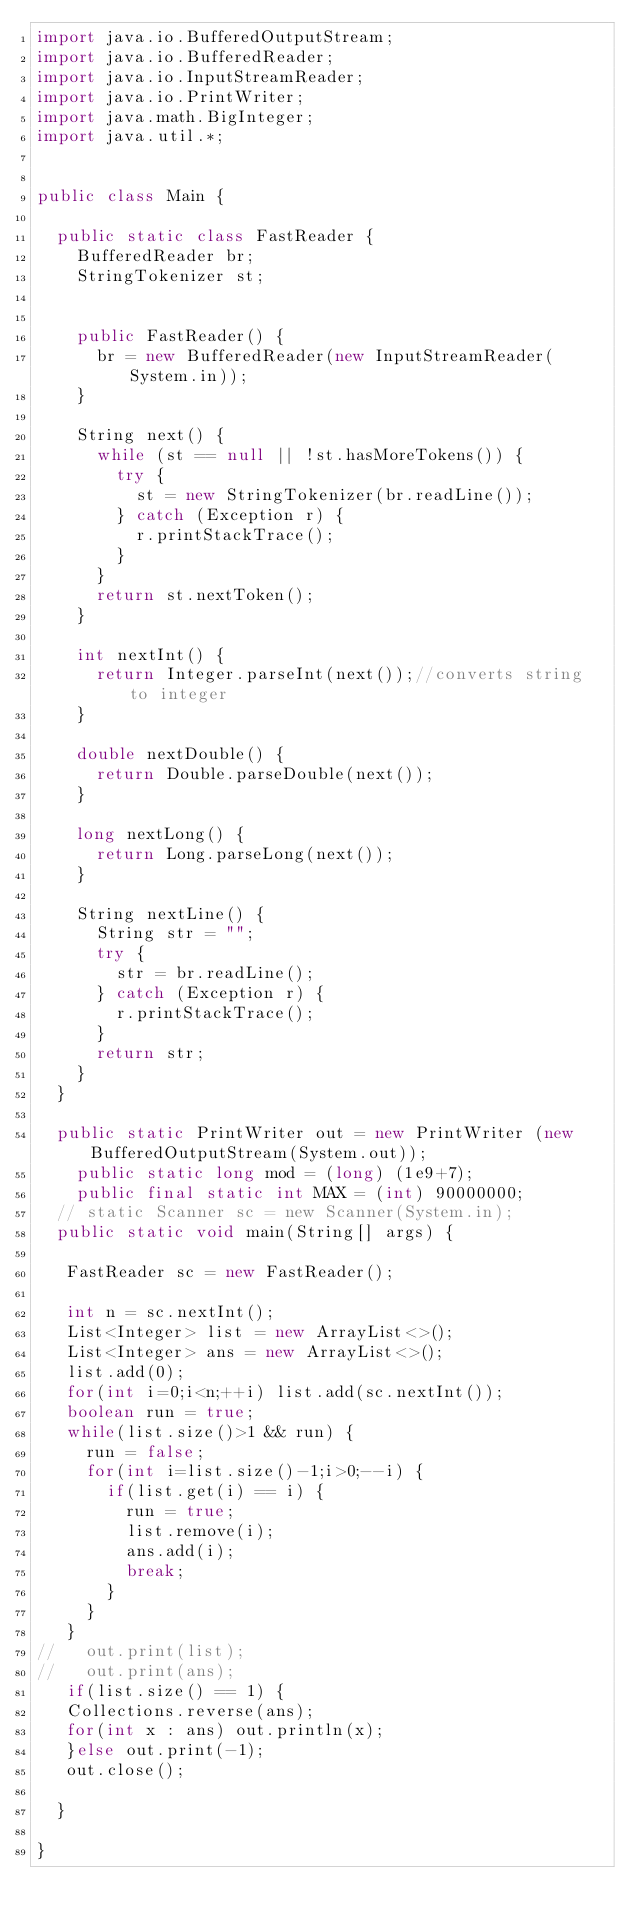Convert code to text. <code><loc_0><loc_0><loc_500><loc_500><_Java_>import java.io.BufferedOutputStream;
import java.io.BufferedReader;
import java.io.InputStreamReader;
import java.io.PrintWriter;
import java.math.BigInteger;
import java.util.*;


public class Main {
	
	public static class FastReader {
		BufferedReader br;
		StringTokenizer st;
	

		public FastReader() {
			br = new BufferedReader(new InputStreamReader(System.in));
		}

		String next() {
			while (st == null || !st.hasMoreTokens()) {
				try {
					st = new StringTokenizer(br.readLine());
				} catch (Exception r) {
					r.printStackTrace();
				}
			}
			return st.nextToken();
		}

		int nextInt() {
			return Integer.parseInt(next());//converts string to integer
		}

		double nextDouble() {
			return Double.parseDouble(next());
		}

		long nextLong() {
			return Long.parseLong(next());
		}

		String nextLine() {
			String str = "";
			try {
				str = br.readLine();
			} catch (Exception r) {
				r.printStackTrace();
			}
			return str;
		}
	}
	
	public static PrintWriter out = new PrintWriter (new BufferedOutputStream(System.out));
    public static long mod = (long) (1e9+7);
    public final static int MAX = (int) 90000000;
  // static Scanner sc = new Scanner(System.in);
	public static void main(String[] args) {
	   
	 FastReader sc = new FastReader();
	
	 int n = sc.nextInt();
	 List<Integer> list = new ArrayList<>();
	 List<Integer> ans = new ArrayList<>();
	 list.add(0);
	 for(int i=0;i<n;++i) list.add(sc.nextInt());
	 boolean run = true;
	 while(list.size()>1 && run) {
		 run = false;
		 for(int i=list.size()-1;i>0;--i) {
			 if(list.get(i) == i) {
				 run = true;
				 list.remove(i);
				 ans.add(i);
				 break;
			 }
		 }
	 }
//	 out.print(list);
//	 out.print(ans);
	 if(list.size() == 1) {
	 Collections.reverse(ans);
	 for(int x : ans) out.println(x);
	 }else out.print(-1);
	 out.close();
		
	}

}</code> 